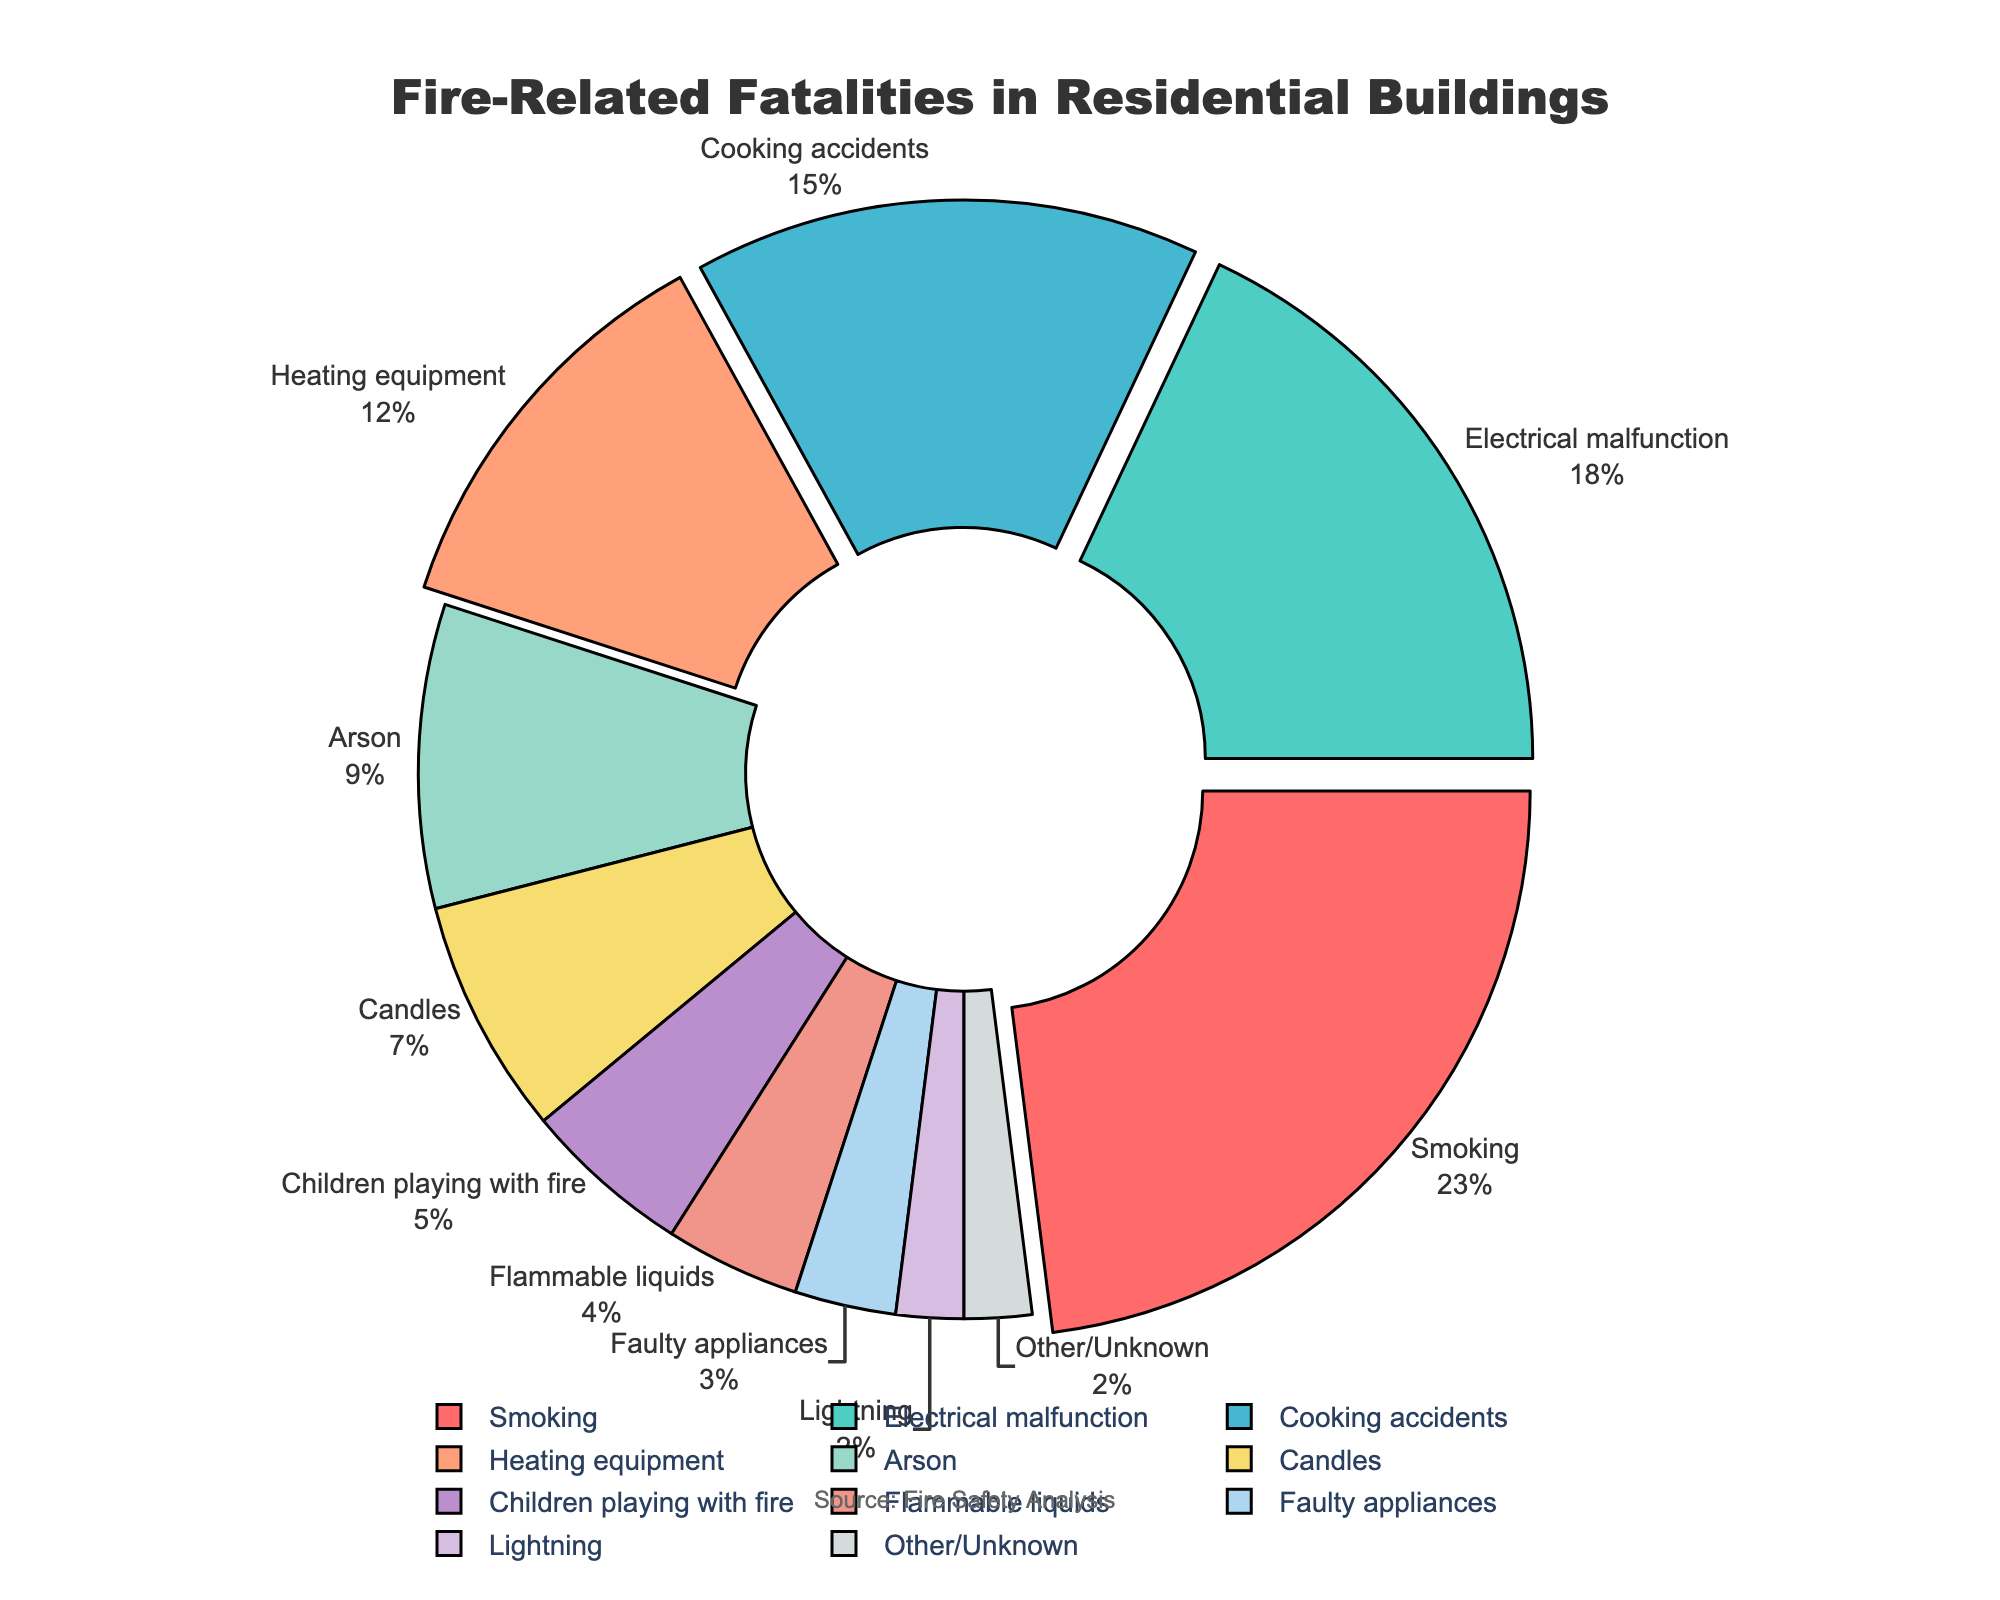What's the leading cause of fire-related fatalities in residential buildings? The figure shows a pie chart with percentages of various causes. The largest segment represents Smoking with 23%.
Answer: Smoking What percentage of fire-related fatalities are due to electrical malfunction and cooking accidents combined? The figure shows that Electrical malfunction accounts for 18% and Cooking accidents account for 15%. The total is 18% + 15% = 33%.
Answer: 33% Which cause has a higher percentage of fire-related fatalities, heating equipment or candles? The figure shows Heating equipment at 12% and Candles at 7%. Thus, Heating equipment has a higher percentage.
Answer: Heating equipment What is the visual difference between segments representing Smoking and Flammable liquids? The Smoking segment is noticeably larger, making up 23% of the pie, while the Flammable liquids segment is much smaller at 4%. The colors are also different, with Smoking being represented by bright red and Flammable liquids by a lighter color.
Answer: Smoking is larger and brighter If we group the causes into two categories: 'Human actions' (Smoking, Cooking accidents, Arson, Candles, Children playing with fire) and 'Equipment issues' (Electrical malfunction, Heating equipment, Faulty appliances), which category has a larger percentage of fire-related fatalities? Human actions include Smoking (23%) + Cooking accidents (15%) + Arson (9%) + Candles (7%) + Children playing with fire (5%) = 59%. Equipment issues include Electrical malfunction (18%) + Heating equipment (12%) + Faulty appliances (3%) = 33%. Thus, Human actions have a larger percentage.
Answer: Human actions Which segments appear to be pulled out in the pie chart? In a pie chart, segments with significant percentages like more than 10% are often pulled out for emphasis. These are Smoking (23%), Electrical malfunction (18%), Cooking accidents (15%), and Heating equipment (12%).
Answer: Smoking, Electrical malfunction, Cooking accidents, Heating equipment What percentage of fire-related fatalities is caused by unidentified sources (Other/Unknown)? The figure shows that Other/Unknown causes account for 2% of the pie.
Answer: 2% How does the percentage of fatalities due to Children playing with fire compare with those due to Flammable liquids? The figure shows that Children playing with fire cause 5% of fatalities, whereas Flammable liquids cause 4%. Thus, Children playing with fire has a slightly higher percentage.
Answer: Children playing with fire What is the difference in the percentage of fire-related fatalities between Smoking and Electrical malfunction? The figure shows Smoking at 23% and Electrical malfunction at 18%. The difference is 23% - 18% = 5%.
Answer: 5% What is the least common cause of fire-related fatalities among the listed categories? The figure shows that Lightning and Other/Unknown causes both have the smallest segments, each representing 2% of the fatalities.
Answer: Lightning, Other/Unknown 